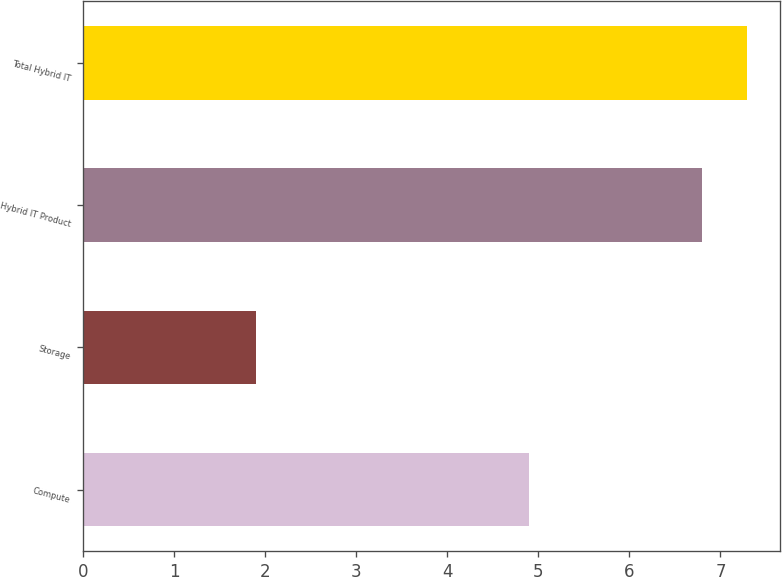Convert chart to OTSL. <chart><loc_0><loc_0><loc_500><loc_500><bar_chart><fcel>Compute<fcel>Storage<fcel>Hybrid IT Product<fcel>Total Hybrid IT<nl><fcel>4.9<fcel>1.9<fcel>6.8<fcel>7.29<nl></chart> 